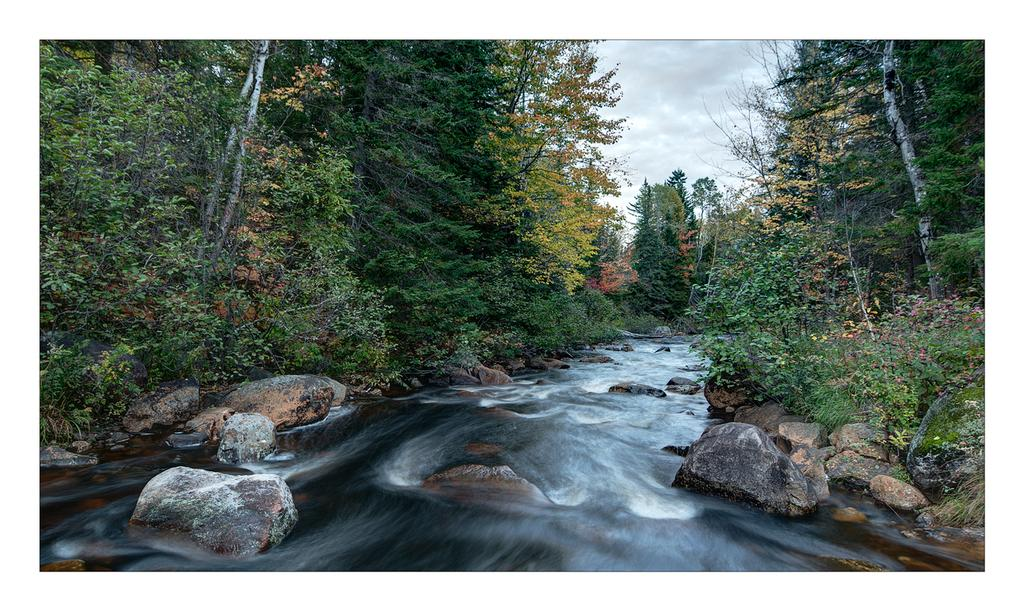What is the main element in the image? There is water in the image. What other objects or features can be seen in the image? There are rocks and trees in the image. Can you describe the trees in the image? The trees have green, yellow, and orange colors. What is visible in the background of the image? The sky is visible in the background of the image. Where is the kitty holding a banana during the event in the image? There is no kitty, banana, or event present in the image. 